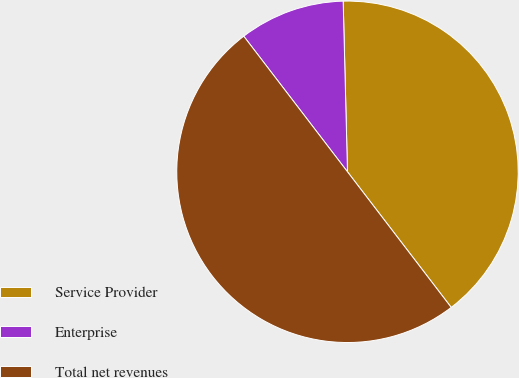Convert chart. <chart><loc_0><loc_0><loc_500><loc_500><pie_chart><fcel>Service Provider<fcel>Enterprise<fcel>Total net revenues<nl><fcel>40.01%<fcel>9.99%<fcel>50.0%<nl></chart> 